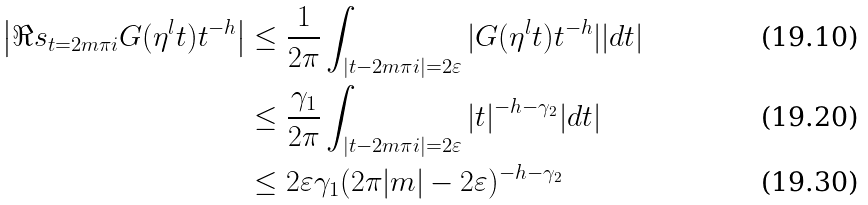Convert formula to latex. <formula><loc_0><loc_0><loc_500><loc_500>\left | \Re s _ { t = 2 m \pi i } G ( \eta ^ { l } t ) t ^ { - h } \right | & \leq \frac { 1 } { 2 \pi } \int _ { | t - 2 m \pi i | = 2 \varepsilon } | G ( \eta ^ { l } t ) t ^ { - h } | | d t | \\ & \leq \frac { \gamma _ { 1 } } { 2 \pi } \int _ { | t - 2 m \pi i | = 2 \varepsilon } | t | ^ { - h - \gamma _ { 2 } } | d t | \\ & \leq 2 \varepsilon \gamma _ { 1 } ( 2 \pi | m | - 2 \varepsilon ) ^ { - h - \gamma _ { 2 } }</formula> 